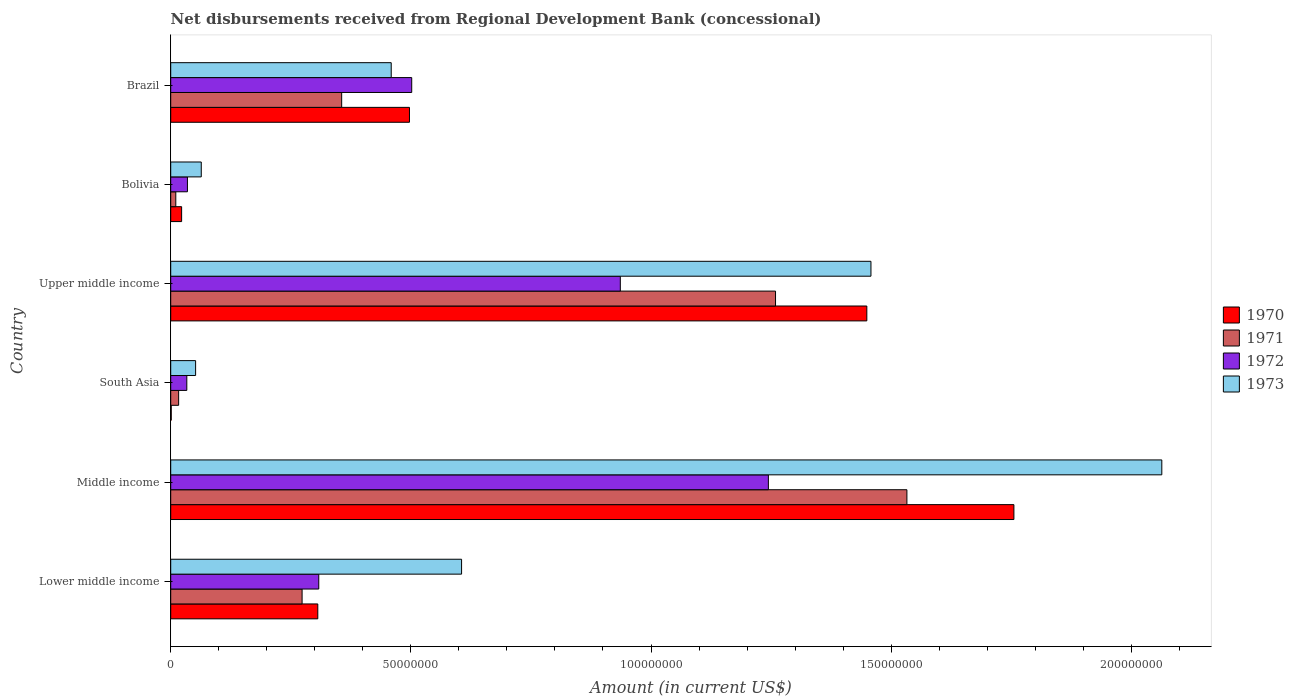How many different coloured bars are there?
Your response must be concise. 4. Are the number of bars on each tick of the Y-axis equal?
Your response must be concise. Yes. How many bars are there on the 1st tick from the top?
Your response must be concise. 4. What is the label of the 4th group of bars from the top?
Provide a short and direct response. South Asia. In how many cases, is the number of bars for a given country not equal to the number of legend labels?
Your response must be concise. 0. What is the amount of disbursements received from Regional Development Bank in 1972 in Bolivia?
Your response must be concise. 3.48e+06. Across all countries, what is the maximum amount of disbursements received from Regional Development Bank in 1970?
Offer a terse response. 1.76e+08. Across all countries, what is the minimum amount of disbursements received from Regional Development Bank in 1973?
Provide a succinct answer. 5.18e+06. In which country was the amount of disbursements received from Regional Development Bank in 1970 minimum?
Provide a short and direct response. South Asia. What is the total amount of disbursements received from Regional Development Bank in 1973 in the graph?
Keep it short and to the point. 4.70e+08. What is the difference between the amount of disbursements received from Regional Development Bank in 1971 in Middle income and that in South Asia?
Keep it short and to the point. 1.52e+08. What is the difference between the amount of disbursements received from Regional Development Bank in 1972 in South Asia and the amount of disbursements received from Regional Development Bank in 1973 in Middle income?
Offer a terse response. -2.03e+08. What is the average amount of disbursements received from Regional Development Bank in 1970 per country?
Provide a succinct answer. 6.72e+07. What is the difference between the amount of disbursements received from Regional Development Bank in 1970 and amount of disbursements received from Regional Development Bank in 1971 in Middle income?
Keep it short and to the point. 2.23e+07. What is the ratio of the amount of disbursements received from Regional Development Bank in 1972 in Bolivia to that in South Asia?
Offer a very short reply. 1.04. Is the difference between the amount of disbursements received from Regional Development Bank in 1970 in South Asia and Upper middle income greater than the difference between the amount of disbursements received from Regional Development Bank in 1971 in South Asia and Upper middle income?
Your answer should be very brief. No. What is the difference between the highest and the second highest amount of disbursements received from Regional Development Bank in 1973?
Provide a short and direct response. 6.06e+07. What is the difference between the highest and the lowest amount of disbursements received from Regional Development Bank in 1971?
Offer a very short reply. 1.52e+08. In how many countries, is the amount of disbursements received from Regional Development Bank in 1970 greater than the average amount of disbursements received from Regional Development Bank in 1970 taken over all countries?
Offer a terse response. 2. Is it the case that in every country, the sum of the amount of disbursements received from Regional Development Bank in 1973 and amount of disbursements received from Regional Development Bank in 1971 is greater than the sum of amount of disbursements received from Regional Development Bank in 1970 and amount of disbursements received from Regional Development Bank in 1972?
Offer a terse response. No. What does the 2nd bar from the top in Lower middle income represents?
Give a very brief answer. 1972. What does the 1st bar from the bottom in Bolivia represents?
Keep it short and to the point. 1970. How many bars are there?
Give a very brief answer. 24. How many countries are there in the graph?
Offer a very short reply. 6. What is the difference between two consecutive major ticks on the X-axis?
Ensure brevity in your answer.  5.00e+07. Are the values on the major ticks of X-axis written in scientific E-notation?
Ensure brevity in your answer.  No. Does the graph contain any zero values?
Keep it short and to the point. No. Does the graph contain grids?
Make the answer very short. No. How many legend labels are there?
Keep it short and to the point. 4. What is the title of the graph?
Your response must be concise. Net disbursements received from Regional Development Bank (concessional). What is the Amount (in current US$) of 1970 in Lower middle income?
Your response must be concise. 3.06e+07. What is the Amount (in current US$) of 1971 in Lower middle income?
Offer a terse response. 2.74e+07. What is the Amount (in current US$) of 1972 in Lower middle income?
Provide a short and direct response. 3.08e+07. What is the Amount (in current US$) in 1973 in Lower middle income?
Offer a terse response. 6.06e+07. What is the Amount (in current US$) in 1970 in Middle income?
Offer a very short reply. 1.76e+08. What is the Amount (in current US$) in 1971 in Middle income?
Offer a terse response. 1.53e+08. What is the Amount (in current US$) of 1972 in Middle income?
Offer a terse response. 1.24e+08. What is the Amount (in current US$) of 1973 in Middle income?
Offer a terse response. 2.06e+08. What is the Amount (in current US$) of 1970 in South Asia?
Provide a short and direct response. 1.09e+05. What is the Amount (in current US$) in 1971 in South Asia?
Offer a very short reply. 1.65e+06. What is the Amount (in current US$) of 1972 in South Asia?
Your answer should be very brief. 3.35e+06. What is the Amount (in current US$) of 1973 in South Asia?
Your response must be concise. 5.18e+06. What is the Amount (in current US$) of 1970 in Upper middle income?
Ensure brevity in your answer.  1.45e+08. What is the Amount (in current US$) in 1971 in Upper middle income?
Offer a terse response. 1.26e+08. What is the Amount (in current US$) of 1972 in Upper middle income?
Make the answer very short. 9.36e+07. What is the Amount (in current US$) of 1973 in Upper middle income?
Provide a short and direct response. 1.46e+08. What is the Amount (in current US$) in 1970 in Bolivia?
Offer a very short reply. 2.27e+06. What is the Amount (in current US$) in 1971 in Bolivia?
Offer a terse response. 1.06e+06. What is the Amount (in current US$) of 1972 in Bolivia?
Give a very brief answer. 3.48e+06. What is the Amount (in current US$) of 1973 in Bolivia?
Offer a terse response. 6.36e+06. What is the Amount (in current US$) of 1970 in Brazil?
Make the answer very short. 4.97e+07. What is the Amount (in current US$) in 1971 in Brazil?
Your answer should be very brief. 3.56e+07. What is the Amount (in current US$) of 1972 in Brazil?
Your answer should be very brief. 5.02e+07. What is the Amount (in current US$) in 1973 in Brazil?
Offer a very short reply. 4.59e+07. Across all countries, what is the maximum Amount (in current US$) in 1970?
Give a very brief answer. 1.76e+08. Across all countries, what is the maximum Amount (in current US$) in 1971?
Provide a succinct answer. 1.53e+08. Across all countries, what is the maximum Amount (in current US$) of 1972?
Give a very brief answer. 1.24e+08. Across all countries, what is the maximum Amount (in current US$) of 1973?
Offer a terse response. 2.06e+08. Across all countries, what is the minimum Amount (in current US$) in 1970?
Your answer should be very brief. 1.09e+05. Across all countries, what is the minimum Amount (in current US$) of 1971?
Offer a very short reply. 1.06e+06. Across all countries, what is the minimum Amount (in current US$) in 1972?
Your answer should be very brief. 3.35e+06. Across all countries, what is the minimum Amount (in current US$) in 1973?
Provide a succinct answer. 5.18e+06. What is the total Amount (in current US$) in 1970 in the graph?
Make the answer very short. 4.03e+08. What is the total Amount (in current US$) of 1971 in the graph?
Your answer should be compact. 3.45e+08. What is the total Amount (in current US$) of 1972 in the graph?
Make the answer very short. 3.06e+08. What is the total Amount (in current US$) in 1973 in the graph?
Offer a very short reply. 4.70e+08. What is the difference between the Amount (in current US$) of 1970 in Lower middle income and that in Middle income?
Ensure brevity in your answer.  -1.45e+08. What is the difference between the Amount (in current US$) in 1971 in Lower middle income and that in Middle income?
Your answer should be very brief. -1.26e+08. What is the difference between the Amount (in current US$) in 1972 in Lower middle income and that in Middle income?
Provide a short and direct response. -9.36e+07. What is the difference between the Amount (in current US$) of 1973 in Lower middle income and that in Middle income?
Make the answer very short. -1.46e+08. What is the difference between the Amount (in current US$) in 1970 in Lower middle income and that in South Asia?
Offer a very short reply. 3.05e+07. What is the difference between the Amount (in current US$) of 1971 in Lower middle income and that in South Asia?
Give a very brief answer. 2.57e+07. What is the difference between the Amount (in current US$) in 1972 in Lower middle income and that in South Asia?
Give a very brief answer. 2.75e+07. What is the difference between the Amount (in current US$) of 1973 in Lower middle income and that in South Asia?
Provide a short and direct response. 5.54e+07. What is the difference between the Amount (in current US$) of 1970 in Lower middle income and that in Upper middle income?
Provide a short and direct response. -1.14e+08. What is the difference between the Amount (in current US$) of 1971 in Lower middle income and that in Upper middle income?
Offer a terse response. -9.86e+07. What is the difference between the Amount (in current US$) of 1972 in Lower middle income and that in Upper middle income?
Provide a succinct answer. -6.28e+07. What is the difference between the Amount (in current US$) in 1973 in Lower middle income and that in Upper middle income?
Provide a succinct answer. -8.52e+07. What is the difference between the Amount (in current US$) of 1970 in Lower middle income and that in Bolivia?
Provide a succinct answer. 2.84e+07. What is the difference between the Amount (in current US$) of 1971 in Lower middle income and that in Bolivia?
Provide a succinct answer. 2.63e+07. What is the difference between the Amount (in current US$) in 1972 in Lower middle income and that in Bolivia?
Provide a succinct answer. 2.73e+07. What is the difference between the Amount (in current US$) of 1973 in Lower middle income and that in Bolivia?
Make the answer very short. 5.42e+07. What is the difference between the Amount (in current US$) in 1970 in Lower middle income and that in Brazil?
Offer a very short reply. -1.91e+07. What is the difference between the Amount (in current US$) in 1971 in Lower middle income and that in Brazil?
Offer a terse response. -8.24e+06. What is the difference between the Amount (in current US$) of 1972 in Lower middle income and that in Brazil?
Offer a terse response. -1.94e+07. What is the difference between the Amount (in current US$) in 1973 in Lower middle income and that in Brazil?
Keep it short and to the point. 1.46e+07. What is the difference between the Amount (in current US$) in 1970 in Middle income and that in South Asia?
Your response must be concise. 1.75e+08. What is the difference between the Amount (in current US$) of 1971 in Middle income and that in South Asia?
Keep it short and to the point. 1.52e+08. What is the difference between the Amount (in current US$) in 1972 in Middle income and that in South Asia?
Ensure brevity in your answer.  1.21e+08. What is the difference between the Amount (in current US$) in 1973 in Middle income and that in South Asia?
Offer a very short reply. 2.01e+08. What is the difference between the Amount (in current US$) in 1970 in Middle income and that in Upper middle income?
Your answer should be very brief. 3.06e+07. What is the difference between the Amount (in current US$) in 1971 in Middle income and that in Upper middle income?
Provide a short and direct response. 2.74e+07. What is the difference between the Amount (in current US$) in 1972 in Middle income and that in Upper middle income?
Your answer should be very brief. 3.08e+07. What is the difference between the Amount (in current US$) of 1973 in Middle income and that in Upper middle income?
Give a very brief answer. 6.06e+07. What is the difference between the Amount (in current US$) of 1970 in Middle income and that in Bolivia?
Offer a very short reply. 1.73e+08. What is the difference between the Amount (in current US$) of 1971 in Middle income and that in Bolivia?
Provide a succinct answer. 1.52e+08. What is the difference between the Amount (in current US$) of 1972 in Middle income and that in Bolivia?
Give a very brief answer. 1.21e+08. What is the difference between the Amount (in current US$) in 1973 in Middle income and that in Bolivia?
Your response must be concise. 2.00e+08. What is the difference between the Amount (in current US$) of 1970 in Middle income and that in Brazil?
Give a very brief answer. 1.26e+08. What is the difference between the Amount (in current US$) in 1971 in Middle income and that in Brazil?
Your response must be concise. 1.18e+08. What is the difference between the Amount (in current US$) in 1972 in Middle income and that in Brazil?
Offer a terse response. 7.43e+07. What is the difference between the Amount (in current US$) of 1973 in Middle income and that in Brazil?
Offer a very short reply. 1.60e+08. What is the difference between the Amount (in current US$) in 1970 in South Asia and that in Upper middle income?
Your answer should be very brief. -1.45e+08. What is the difference between the Amount (in current US$) in 1971 in South Asia and that in Upper middle income?
Keep it short and to the point. -1.24e+08. What is the difference between the Amount (in current US$) in 1972 in South Asia and that in Upper middle income?
Your answer should be very brief. -9.03e+07. What is the difference between the Amount (in current US$) in 1973 in South Asia and that in Upper middle income?
Provide a short and direct response. -1.41e+08. What is the difference between the Amount (in current US$) in 1970 in South Asia and that in Bolivia?
Your answer should be very brief. -2.16e+06. What is the difference between the Amount (in current US$) of 1971 in South Asia and that in Bolivia?
Make the answer very short. 5.92e+05. What is the difference between the Amount (in current US$) of 1972 in South Asia and that in Bolivia?
Ensure brevity in your answer.  -1.30e+05. What is the difference between the Amount (in current US$) in 1973 in South Asia and that in Bolivia?
Offer a very short reply. -1.18e+06. What is the difference between the Amount (in current US$) of 1970 in South Asia and that in Brazil?
Offer a very short reply. -4.96e+07. What is the difference between the Amount (in current US$) of 1971 in South Asia and that in Brazil?
Offer a very short reply. -3.39e+07. What is the difference between the Amount (in current US$) in 1972 in South Asia and that in Brazil?
Keep it short and to the point. -4.68e+07. What is the difference between the Amount (in current US$) in 1973 in South Asia and that in Brazil?
Your answer should be very brief. -4.07e+07. What is the difference between the Amount (in current US$) of 1970 in Upper middle income and that in Bolivia?
Provide a succinct answer. 1.43e+08. What is the difference between the Amount (in current US$) of 1971 in Upper middle income and that in Bolivia?
Your answer should be compact. 1.25e+08. What is the difference between the Amount (in current US$) in 1972 in Upper middle income and that in Bolivia?
Provide a short and direct response. 9.01e+07. What is the difference between the Amount (in current US$) in 1973 in Upper middle income and that in Bolivia?
Give a very brief answer. 1.39e+08. What is the difference between the Amount (in current US$) in 1970 in Upper middle income and that in Brazil?
Keep it short and to the point. 9.52e+07. What is the difference between the Amount (in current US$) in 1971 in Upper middle income and that in Brazil?
Your answer should be very brief. 9.03e+07. What is the difference between the Amount (in current US$) in 1972 in Upper middle income and that in Brazil?
Your response must be concise. 4.34e+07. What is the difference between the Amount (in current US$) of 1973 in Upper middle income and that in Brazil?
Offer a very short reply. 9.99e+07. What is the difference between the Amount (in current US$) of 1970 in Bolivia and that in Brazil?
Provide a short and direct response. -4.74e+07. What is the difference between the Amount (in current US$) of 1971 in Bolivia and that in Brazil?
Make the answer very short. -3.45e+07. What is the difference between the Amount (in current US$) of 1972 in Bolivia and that in Brazil?
Provide a succinct answer. -4.67e+07. What is the difference between the Amount (in current US$) of 1973 in Bolivia and that in Brazil?
Offer a terse response. -3.95e+07. What is the difference between the Amount (in current US$) of 1970 in Lower middle income and the Amount (in current US$) of 1971 in Middle income?
Give a very brief answer. -1.23e+08. What is the difference between the Amount (in current US$) in 1970 in Lower middle income and the Amount (in current US$) in 1972 in Middle income?
Your answer should be very brief. -9.38e+07. What is the difference between the Amount (in current US$) of 1970 in Lower middle income and the Amount (in current US$) of 1973 in Middle income?
Make the answer very short. -1.76e+08. What is the difference between the Amount (in current US$) of 1971 in Lower middle income and the Amount (in current US$) of 1972 in Middle income?
Give a very brief answer. -9.71e+07. What is the difference between the Amount (in current US$) in 1971 in Lower middle income and the Amount (in current US$) in 1973 in Middle income?
Give a very brief answer. -1.79e+08. What is the difference between the Amount (in current US$) in 1972 in Lower middle income and the Amount (in current US$) in 1973 in Middle income?
Give a very brief answer. -1.76e+08. What is the difference between the Amount (in current US$) in 1970 in Lower middle income and the Amount (in current US$) in 1971 in South Asia?
Your answer should be very brief. 2.90e+07. What is the difference between the Amount (in current US$) of 1970 in Lower middle income and the Amount (in current US$) of 1972 in South Asia?
Your response must be concise. 2.73e+07. What is the difference between the Amount (in current US$) of 1970 in Lower middle income and the Amount (in current US$) of 1973 in South Asia?
Provide a succinct answer. 2.54e+07. What is the difference between the Amount (in current US$) in 1971 in Lower middle income and the Amount (in current US$) in 1972 in South Asia?
Provide a succinct answer. 2.40e+07. What is the difference between the Amount (in current US$) in 1971 in Lower middle income and the Amount (in current US$) in 1973 in South Asia?
Keep it short and to the point. 2.22e+07. What is the difference between the Amount (in current US$) in 1972 in Lower middle income and the Amount (in current US$) in 1973 in South Asia?
Offer a terse response. 2.56e+07. What is the difference between the Amount (in current US$) in 1970 in Lower middle income and the Amount (in current US$) in 1971 in Upper middle income?
Offer a very short reply. -9.53e+07. What is the difference between the Amount (in current US$) in 1970 in Lower middle income and the Amount (in current US$) in 1972 in Upper middle income?
Your answer should be compact. -6.30e+07. What is the difference between the Amount (in current US$) of 1970 in Lower middle income and the Amount (in current US$) of 1973 in Upper middle income?
Keep it short and to the point. -1.15e+08. What is the difference between the Amount (in current US$) of 1971 in Lower middle income and the Amount (in current US$) of 1972 in Upper middle income?
Provide a succinct answer. -6.63e+07. What is the difference between the Amount (in current US$) in 1971 in Lower middle income and the Amount (in current US$) in 1973 in Upper middle income?
Give a very brief answer. -1.18e+08. What is the difference between the Amount (in current US$) of 1972 in Lower middle income and the Amount (in current US$) of 1973 in Upper middle income?
Provide a short and direct response. -1.15e+08. What is the difference between the Amount (in current US$) in 1970 in Lower middle income and the Amount (in current US$) in 1971 in Bolivia?
Provide a succinct answer. 2.96e+07. What is the difference between the Amount (in current US$) in 1970 in Lower middle income and the Amount (in current US$) in 1972 in Bolivia?
Your response must be concise. 2.71e+07. What is the difference between the Amount (in current US$) of 1970 in Lower middle income and the Amount (in current US$) of 1973 in Bolivia?
Your answer should be very brief. 2.43e+07. What is the difference between the Amount (in current US$) of 1971 in Lower middle income and the Amount (in current US$) of 1972 in Bolivia?
Your answer should be compact. 2.39e+07. What is the difference between the Amount (in current US$) in 1971 in Lower middle income and the Amount (in current US$) in 1973 in Bolivia?
Provide a short and direct response. 2.10e+07. What is the difference between the Amount (in current US$) in 1972 in Lower middle income and the Amount (in current US$) in 1973 in Bolivia?
Offer a very short reply. 2.45e+07. What is the difference between the Amount (in current US$) in 1970 in Lower middle income and the Amount (in current US$) in 1971 in Brazil?
Ensure brevity in your answer.  -4.97e+06. What is the difference between the Amount (in current US$) in 1970 in Lower middle income and the Amount (in current US$) in 1972 in Brazil?
Your answer should be compact. -1.96e+07. What is the difference between the Amount (in current US$) in 1970 in Lower middle income and the Amount (in current US$) in 1973 in Brazil?
Offer a very short reply. -1.53e+07. What is the difference between the Amount (in current US$) of 1971 in Lower middle income and the Amount (in current US$) of 1972 in Brazil?
Ensure brevity in your answer.  -2.28e+07. What is the difference between the Amount (in current US$) of 1971 in Lower middle income and the Amount (in current US$) of 1973 in Brazil?
Your response must be concise. -1.86e+07. What is the difference between the Amount (in current US$) of 1972 in Lower middle income and the Amount (in current US$) of 1973 in Brazil?
Offer a terse response. -1.51e+07. What is the difference between the Amount (in current US$) in 1970 in Middle income and the Amount (in current US$) in 1971 in South Asia?
Ensure brevity in your answer.  1.74e+08. What is the difference between the Amount (in current US$) of 1970 in Middle income and the Amount (in current US$) of 1972 in South Asia?
Make the answer very short. 1.72e+08. What is the difference between the Amount (in current US$) in 1970 in Middle income and the Amount (in current US$) in 1973 in South Asia?
Provide a short and direct response. 1.70e+08. What is the difference between the Amount (in current US$) in 1971 in Middle income and the Amount (in current US$) in 1972 in South Asia?
Your answer should be compact. 1.50e+08. What is the difference between the Amount (in current US$) in 1971 in Middle income and the Amount (in current US$) in 1973 in South Asia?
Offer a very short reply. 1.48e+08. What is the difference between the Amount (in current US$) of 1972 in Middle income and the Amount (in current US$) of 1973 in South Asia?
Keep it short and to the point. 1.19e+08. What is the difference between the Amount (in current US$) in 1970 in Middle income and the Amount (in current US$) in 1971 in Upper middle income?
Your response must be concise. 4.96e+07. What is the difference between the Amount (in current US$) in 1970 in Middle income and the Amount (in current US$) in 1972 in Upper middle income?
Give a very brief answer. 8.19e+07. What is the difference between the Amount (in current US$) of 1970 in Middle income and the Amount (in current US$) of 1973 in Upper middle income?
Your response must be concise. 2.98e+07. What is the difference between the Amount (in current US$) in 1971 in Middle income and the Amount (in current US$) in 1972 in Upper middle income?
Make the answer very short. 5.97e+07. What is the difference between the Amount (in current US$) of 1971 in Middle income and the Amount (in current US$) of 1973 in Upper middle income?
Give a very brief answer. 7.49e+06. What is the difference between the Amount (in current US$) of 1972 in Middle income and the Amount (in current US$) of 1973 in Upper middle income?
Your answer should be very brief. -2.14e+07. What is the difference between the Amount (in current US$) of 1970 in Middle income and the Amount (in current US$) of 1971 in Bolivia?
Ensure brevity in your answer.  1.74e+08. What is the difference between the Amount (in current US$) in 1970 in Middle income and the Amount (in current US$) in 1972 in Bolivia?
Your answer should be compact. 1.72e+08. What is the difference between the Amount (in current US$) in 1970 in Middle income and the Amount (in current US$) in 1973 in Bolivia?
Your answer should be very brief. 1.69e+08. What is the difference between the Amount (in current US$) of 1971 in Middle income and the Amount (in current US$) of 1972 in Bolivia?
Your answer should be very brief. 1.50e+08. What is the difference between the Amount (in current US$) of 1971 in Middle income and the Amount (in current US$) of 1973 in Bolivia?
Your response must be concise. 1.47e+08. What is the difference between the Amount (in current US$) in 1972 in Middle income and the Amount (in current US$) in 1973 in Bolivia?
Make the answer very short. 1.18e+08. What is the difference between the Amount (in current US$) in 1970 in Middle income and the Amount (in current US$) in 1971 in Brazil?
Your response must be concise. 1.40e+08. What is the difference between the Amount (in current US$) of 1970 in Middle income and the Amount (in current US$) of 1972 in Brazil?
Make the answer very short. 1.25e+08. What is the difference between the Amount (in current US$) of 1970 in Middle income and the Amount (in current US$) of 1973 in Brazil?
Your answer should be compact. 1.30e+08. What is the difference between the Amount (in current US$) of 1971 in Middle income and the Amount (in current US$) of 1972 in Brazil?
Make the answer very short. 1.03e+08. What is the difference between the Amount (in current US$) in 1971 in Middle income and the Amount (in current US$) in 1973 in Brazil?
Your answer should be very brief. 1.07e+08. What is the difference between the Amount (in current US$) of 1972 in Middle income and the Amount (in current US$) of 1973 in Brazil?
Offer a very short reply. 7.85e+07. What is the difference between the Amount (in current US$) in 1970 in South Asia and the Amount (in current US$) in 1971 in Upper middle income?
Ensure brevity in your answer.  -1.26e+08. What is the difference between the Amount (in current US$) of 1970 in South Asia and the Amount (in current US$) of 1972 in Upper middle income?
Provide a short and direct response. -9.35e+07. What is the difference between the Amount (in current US$) in 1970 in South Asia and the Amount (in current US$) in 1973 in Upper middle income?
Give a very brief answer. -1.46e+08. What is the difference between the Amount (in current US$) in 1971 in South Asia and the Amount (in current US$) in 1972 in Upper middle income?
Your answer should be very brief. -9.20e+07. What is the difference between the Amount (in current US$) of 1971 in South Asia and the Amount (in current US$) of 1973 in Upper middle income?
Provide a succinct answer. -1.44e+08. What is the difference between the Amount (in current US$) of 1972 in South Asia and the Amount (in current US$) of 1973 in Upper middle income?
Offer a terse response. -1.42e+08. What is the difference between the Amount (in current US$) in 1970 in South Asia and the Amount (in current US$) in 1971 in Bolivia?
Make the answer very short. -9.49e+05. What is the difference between the Amount (in current US$) in 1970 in South Asia and the Amount (in current US$) in 1972 in Bolivia?
Offer a very short reply. -3.37e+06. What is the difference between the Amount (in current US$) in 1970 in South Asia and the Amount (in current US$) in 1973 in Bolivia?
Offer a terse response. -6.25e+06. What is the difference between the Amount (in current US$) in 1971 in South Asia and the Amount (in current US$) in 1972 in Bolivia?
Your answer should be very brief. -1.83e+06. What is the difference between the Amount (in current US$) of 1971 in South Asia and the Amount (in current US$) of 1973 in Bolivia?
Offer a terse response. -4.71e+06. What is the difference between the Amount (in current US$) in 1972 in South Asia and the Amount (in current US$) in 1973 in Bolivia?
Keep it short and to the point. -3.01e+06. What is the difference between the Amount (in current US$) of 1970 in South Asia and the Amount (in current US$) of 1971 in Brazil?
Your response must be concise. -3.55e+07. What is the difference between the Amount (in current US$) in 1970 in South Asia and the Amount (in current US$) in 1972 in Brazil?
Offer a very short reply. -5.01e+07. What is the difference between the Amount (in current US$) in 1970 in South Asia and the Amount (in current US$) in 1973 in Brazil?
Make the answer very short. -4.58e+07. What is the difference between the Amount (in current US$) of 1971 in South Asia and the Amount (in current US$) of 1972 in Brazil?
Provide a succinct answer. -4.85e+07. What is the difference between the Amount (in current US$) in 1971 in South Asia and the Amount (in current US$) in 1973 in Brazil?
Your answer should be very brief. -4.43e+07. What is the difference between the Amount (in current US$) of 1972 in South Asia and the Amount (in current US$) of 1973 in Brazil?
Your answer should be compact. -4.26e+07. What is the difference between the Amount (in current US$) in 1970 in Upper middle income and the Amount (in current US$) in 1971 in Bolivia?
Give a very brief answer. 1.44e+08. What is the difference between the Amount (in current US$) in 1970 in Upper middle income and the Amount (in current US$) in 1972 in Bolivia?
Keep it short and to the point. 1.41e+08. What is the difference between the Amount (in current US$) of 1970 in Upper middle income and the Amount (in current US$) of 1973 in Bolivia?
Your answer should be very brief. 1.39e+08. What is the difference between the Amount (in current US$) in 1971 in Upper middle income and the Amount (in current US$) in 1972 in Bolivia?
Ensure brevity in your answer.  1.22e+08. What is the difference between the Amount (in current US$) in 1971 in Upper middle income and the Amount (in current US$) in 1973 in Bolivia?
Your answer should be compact. 1.20e+08. What is the difference between the Amount (in current US$) of 1972 in Upper middle income and the Amount (in current US$) of 1973 in Bolivia?
Provide a succinct answer. 8.72e+07. What is the difference between the Amount (in current US$) in 1970 in Upper middle income and the Amount (in current US$) in 1971 in Brazil?
Offer a very short reply. 1.09e+08. What is the difference between the Amount (in current US$) in 1970 in Upper middle income and the Amount (in current US$) in 1972 in Brazil?
Offer a terse response. 9.48e+07. What is the difference between the Amount (in current US$) of 1970 in Upper middle income and the Amount (in current US$) of 1973 in Brazil?
Your answer should be compact. 9.90e+07. What is the difference between the Amount (in current US$) in 1971 in Upper middle income and the Amount (in current US$) in 1972 in Brazil?
Provide a succinct answer. 7.57e+07. What is the difference between the Amount (in current US$) in 1971 in Upper middle income and the Amount (in current US$) in 1973 in Brazil?
Provide a succinct answer. 8.00e+07. What is the difference between the Amount (in current US$) in 1972 in Upper middle income and the Amount (in current US$) in 1973 in Brazil?
Your response must be concise. 4.77e+07. What is the difference between the Amount (in current US$) of 1970 in Bolivia and the Amount (in current US$) of 1971 in Brazil?
Ensure brevity in your answer.  -3.33e+07. What is the difference between the Amount (in current US$) of 1970 in Bolivia and the Amount (in current US$) of 1972 in Brazil?
Keep it short and to the point. -4.79e+07. What is the difference between the Amount (in current US$) in 1970 in Bolivia and the Amount (in current US$) in 1973 in Brazil?
Provide a short and direct response. -4.36e+07. What is the difference between the Amount (in current US$) in 1971 in Bolivia and the Amount (in current US$) in 1972 in Brazil?
Provide a short and direct response. -4.91e+07. What is the difference between the Amount (in current US$) in 1971 in Bolivia and the Amount (in current US$) in 1973 in Brazil?
Your answer should be very brief. -4.49e+07. What is the difference between the Amount (in current US$) of 1972 in Bolivia and the Amount (in current US$) of 1973 in Brazil?
Your response must be concise. -4.24e+07. What is the average Amount (in current US$) in 1970 per country?
Your answer should be compact. 6.72e+07. What is the average Amount (in current US$) of 1971 per country?
Give a very brief answer. 5.75e+07. What is the average Amount (in current US$) in 1972 per country?
Your answer should be very brief. 5.10e+07. What is the average Amount (in current US$) of 1973 per country?
Provide a succinct answer. 7.84e+07. What is the difference between the Amount (in current US$) of 1970 and Amount (in current US$) of 1971 in Lower middle income?
Give a very brief answer. 3.27e+06. What is the difference between the Amount (in current US$) in 1970 and Amount (in current US$) in 1972 in Lower middle income?
Offer a terse response. -2.02e+05. What is the difference between the Amount (in current US$) of 1970 and Amount (in current US$) of 1973 in Lower middle income?
Provide a short and direct response. -2.99e+07. What is the difference between the Amount (in current US$) of 1971 and Amount (in current US$) of 1972 in Lower middle income?
Give a very brief answer. -3.47e+06. What is the difference between the Amount (in current US$) in 1971 and Amount (in current US$) in 1973 in Lower middle income?
Make the answer very short. -3.32e+07. What is the difference between the Amount (in current US$) of 1972 and Amount (in current US$) of 1973 in Lower middle income?
Provide a short and direct response. -2.97e+07. What is the difference between the Amount (in current US$) of 1970 and Amount (in current US$) of 1971 in Middle income?
Keep it short and to the point. 2.23e+07. What is the difference between the Amount (in current US$) of 1970 and Amount (in current US$) of 1972 in Middle income?
Provide a short and direct response. 5.11e+07. What is the difference between the Amount (in current US$) in 1970 and Amount (in current US$) in 1973 in Middle income?
Your response must be concise. -3.08e+07. What is the difference between the Amount (in current US$) in 1971 and Amount (in current US$) in 1972 in Middle income?
Keep it short and to the point. 2.88e+07. What is the difference between the Amount (in current US$) in 1971 and Amount (in current US$) in 1973 in Middle income?
Your answer should be very brief. -5.31e+07. What is the difference between the Amount (in current US$) in 1972 and Amount (in current US$) in 1973 in Middle income?
Provide a succinct answer. -8.19e+07. What is the difference between the Amount (in current US$) of 1970 and Amount (in current US$) of 1971 in South Asia?
Provide a succinct answer. -1.54e+06. What is the difference between the Amount (in current US$) of 1970 and Amount (in current US$) of 1972 in South Asia?
Make the answer very short. -3.24e+06. What is the difference between the Amount (in current US$) of 1970 and Amount (in current US$) of 1973 in South Asia?
Your response must be concise. -5.08e+06. What is the difference between the Amount (in current US$) in 1971 and Amount (in current US$) in 1972 in South Asia?
Make the answer very short. -1.70e+06. What is the difference between the Amount (in current US$) in 1971 and Amount (in current US$) in 1973 in South Asia?
Your response must be concise. -3.53e+06. What is the difference between the Amount (in current US$) in 1972 and Amount (in current US$) in 1973 in South Asia?
Keep it short and to the point. -1.83e+06. What is the difference between the Amount (in current US$) in 1970 and Amount (in current US$) in 1971 in Upper middle income?
Give a very brief answer. 1.90e+07. What is the difference between the Amount (in current US$) in 1970 and Amount (in current US$) in 1972 in Upper middle income?
Offer a very short reply. 5.13e+07. What is the difference between the Amount (in current US$) in 1970 and Amount (in current US$) in 1973 in Upper middle income?
Make the answer very short. -8.58e+05. What is the difference between the Amount (in current US$) in 1971 and Amount (in current US$) in 1972 in Upper middle income?
Provide a succinct answer. 3.23e+07. What is the difference between the Amount (in current US$) of 1971 and Amount (in current US$) of 1973 in Upper middle income?
Your answer should be compact. -1.99e+07. What is the difference between the Amount (in current US$) of 1972 and Amount (in current US$) of 1973 in Upper middle income?
Your answer should be compact. -5.22e+07. What is the difference between the Amount (in current US$) in 1970 and Amount (in current US$) in 1971 in Bolivia?
Provide a short and direct response. 1.21e+06. What is the difference between the Amount (in current US$) in 1970 and Amount (in current US$) in 1972 in Bolivia?
Offer a very short reply. -1.21e+06. What is the difference between the Amount (in current US$) of 1970 and Amount (in current US$) of 1973 in Bolivia?
Offer a terse response. -4.09e+06. What is the difference between the Amount (in current US$) of 1971 and Amount (in current US$) of 1972 in Bolivia?
Make the answer very short. -2.42e+06. What is the difference between the Amount (in current US$) in 1971 and Amount (in current US$) in 1973 in Bolivia?
Your answer should be compact. -5.30e+06. What is the difference between the Amount (in current US$) in 1972 and Amount (in current US$) in 1973 in Bolivia?
Make the answer very short. -2.88e+06. What is the difference between the Amount (in current US$) in 1970 and Amount (in current US$) in 1971 in Brazil?
Keep it short and to the point. 1.41e+07. What is the difference between the Amount (in current US$) of 1970 and Amount (in current US$) of 1972 in Brazil?
Your response must be concise. -4.68e+05. What is the difference between the Amount (in current US$) in 1970 and Amount (in current US$) in 1973 in Brazil?
Keep it short and to the point. 3.80e+06. What is the difference between the Amount (in current US$) in 1971 and Amount (in current US$) in 1972 in Brazil?
Provide a succinct answer. -1.46e+07. What is the difference between the Amount (in current US$) in 1971 and Amount (in current US$) in 1973 in Brazil?
Your response must be concise. -1.03e+07. What is the difference between the Amount (in current US$) in 1972 and Amount (in current US$) in 1973 in Brazil?
Provide a short and direct response. 4.27e+06. What is the ratio of the Amount (in current US$) in 1970 in Lower middle income to that in Middle income?
Your response must be concise. 0.17. What is the ratio of the Amount (in current US$) in 1971 in Lower middle income to that in Middle income?
Provide a succinct answer. 0.18. What is the ratio of the Amount (in current US$) of 1972 in Lower middle income to that in Middle income?
Make the answer very short. 0.25. What is the ratio of the Amount (in current US$) of 1973 in Lower middle income to that in Middle income?
Your answer should be very brief. 0.29. What is the ratio of the Amount (in current US$) in 1970 in Lower middle income to that in South Asia?
Provide a short and direct response. 280.94. What is the ratio of the Amount (in current US$) in 1971 in Lower middle income to that in South Asia?
Your answer should be very brief. 16.58. What is the ratio of the Amount (in current US$) of 1972 in Lower middle income to that in South Asia?
Make the answer very short. 9.2. What is the ratio of the Amount (in current US$) of 1973 in Lower middle income to that in South Asia?
Provide a short and direct response. 11.68. What is the ratio of the Amount (in current US$) of 1970 in Lower middle income to that in Upper middle income?
Make the answer very short. 0.21. What is the ratio of the Amount (in current US$) of 1971 in Lower middle income to that in Upper middle income?
Offer a terse response. 0.22. What is the ratio of the Amount (in current US$) of 1972 in Lower middle income to that in Upper middle income?
Make the answer very short. 0.33. What is the ratio of the Amount (in current US$) in 1973 in Lower middle income to that in Upper middle income?
Your response must be concise. 0.42. What is the ratio of the Amount (in current US$) in 1970 in Lower middle income to that in Bolivia?
Offer a terse response. 13.49. What is the ratio of the Amount (in current US$) of 1971 in Lower middle income to that in Bolivia?
Offer a very short reply. 25.85. What is the ratio of the Amount (in current US$) in 1972 in Lower middle income to that in Bolivia?
Your answer should be very brief. 8.86. What is the ratio of the Amount (in current US$) in 1973 in Lower middle income to that in Bolivia?
Provide a succinct answer. 9.52. What is the ratio of the Amount (in current US$) of 1970 in Lower middle income to that in Brazil?
Your answer should be compact. 0.62. What is the ratio of the Amount (in current US$) of 1971 in Lower middle income to that in Brazil?
Keep it short and to the point. 0.77. What is the ratio of the Amount (in current US$) of 1972 in Lower middle income to that in Brazil?
Provide a short and direct response. 0.61. What is the ratio of the Amount (in current US$) in 1973 in Lower middle income to that in Brazil?
Give a very brief answer. 1.32. What is the ratio of the Amount (in current US$) of 1970 in Middle income to that in South Asia?
Provide a succinct answer. 1610.58. What is the ratio of the Amount (in current US$) of 1971 in Middle income to that in South Asia?
Provide a short and direct response. 92.89. What is the ratio of the Amount (in current US$) in 1972 in Middle income to that in South Asia?
Your response must be concise. 37.14. What is the ratio of the Amount (in current US$) of 1973 in Middle income to that in South Asia?
Provide a succinct answer. 39.8. What is the ratio of the Amount (in current US$) of 1970 in Middle income to that in Upper middle income?
Provide a succinct answer. 1.21. What is the ratio of the Amount (in current US$) of 1971 in Middle income to that in Upper middle income?
Your response must be concise. 1.22. What is the ratio of the Amount (in current US$) in 1972 in Middle income to that in Upper middle income?
Provide a succinct answer. 1.33. What is the ratio of the Amount (in current US$) in 1973 in Middle income to that in Upper middle income?
Ensure brevity in your answer.  1.42. What is the ratio of the Amount (in current US$) of 1970 in Middle income to that in Bolivia?
Your answer should be compact. 77.34. What is the ratio of the Amount (in current US$) of 1971 in Middle income to that in Bolivia?
Make the answer very short. 144.87. What is the ratio of the Amount (in current US$) in 1972 in Middle income to that in Bolivia?
Provide a succinct answer. 35.76. What is the ratio of the Amount (in current US$) of 1973 in Middle income to that in Bolivia?
Make the answer very short. 32.44. What is the ratio of the Amount (in current US$) in 1970 in Middle income to that in Brazil?
Offer a very short reply. 3.53. What is the ratio of the Amount (in current US$) of 1971 in Middle income to that in Brazil?
Offer a terse response. 4.31. What is the ratio of the Amount (in current US$) in 1972 in Middle income to that in Brazil?
Offer a very short reply. 2.48. What is the ratio of the Amount (in current US$) of 1973 in Middle income to that in Brazil?
Provide a succinct answer. 4.49. What is the ratio of the Amount (in current US$) of 1970 in South Asia to that in Upper middle income?
Your answer should be very brief. 0. What is the ratio of the Amount (in current US$) of 1971 in South Asia to that in Upper middle income?
Provide a short and direct response. 0.01. What is the ratio of the Amount (in current US$) of 1972 in South Asia to that in Upper middle income?
Ensure brevity in your answer.  0.04. What is the ratio of the Amount (in current US$) of 1973 in South Asia to that in Upper middle income?
Your answer should be compact. 0.04. What is the ratio of the Amount (in current US$) in 1970 in South Asia to that in Bolivia?
Ensure brevity in your answer.  0.05. What is the ratio of the Amount (in current US$) in 1971 in South Asia to that in Bolivia?
Give a very brief answer. 1.56. What is the ratio of the Amount (in current US$) in 1972 in South Asia to that in Bolivia?
Your response must be concise. 0.96. What is the ratio of the Amount (in current US$) in 1973 in South Asia to that in Bolivia?
Give a very brief answer. 0.82. What is the ratio of the Amount (in current US$) of 1970 in South Asia to that in Brazil?
Your answer should be compact. 0. What is the ratio of the Amount (in current US$) of 1971 in South Asia to that in Brazil?
Offer a terse response. 0.05. What is the ratio of the Amount (in current US$) in 1972 in South Asia to that in Brazil?
Provide a short and direct response. 0.07. What is the ratio of the Amount (in current US$) of 1973 in South Asia to that in Brazil?
Ensure brevity in your answer.  0.11. What is the ratio of the Amount (in current US$) in 1970 in Upper middle income to that in Bolivia?
Your answer should be compact. 63.85. What is the ratio of the Amount (in current US$) in 1971 in Upper middle income to that in Bolivia?
Provide a succinct answer. 119.02. What is the ratio of the Amount (in current US$) of 1972 in Upper middle income to that in Bolivia?
Make the answer very short. 26.9. What is the ratio of the Amount (in current US$) of 1973 in Upper middle income to that in Bolivia?
Make the answer very short. 22.92. What is the ratio of the Amount (in current US$) in 1970 in Upper middle income to that in Brazil?
Give a very brief answer. 2.92. What is the ratio of the Amount (in current US$) of 1971 in Upper middle income to that in Brazil?
Make the answer very short. 3.54. What is the ratio of the Amount (in current US$) of 1972 in Upper middle income to that in Brazil?
Make the answer very short. 1.87. What is the ratio of the Amount (in current US$) in 1973 in Upper middle income to that in Brazil?
Provide a short and direct response. 3.18. What is the ratio of the Amount (in current US$) in 1970 in Bolivia to that in Brazil?
Keep it short and to the point. 0.05. What is the ratio of the Amount (in current US$) of 1971 in Bolivia to that in Brazil?
Provide a succinct answer. 0.03. What is the ratio of the Amount (in current US$) in 1972 in Bolivia to that in Brazil?
Your answer should be very brief. 0.07. What is the ratio of the Amount (in current US$) of 1973 in Bolivia to that in Brazil?
Keep it short and to the point. 0.14. What is the difference between the highest and the second highest Amount (in current US$) of 1970?
Offer a terse response. 3.06e+07. What is the difference between the highest and the second highest Amount (in current US$) of 1971?
Offer a terse response. 2.74e+07. What is the difference between the highest and the second highest Amount (in current US$) in 1972?
Provide a succinct answer. 3.08e+07. What is the difference between the highest and the second highest Amount (in current US$) of 1973?
Provide a short and direct response. 6.06e+07. What is the difference between the highest and the lowest Amount (in current US$) in 1970?
Offer a terse response. 1.75e+08. What is the difference between the highest and the lowest Amount (in current US$) of 1971?
Make the answer very short. 1.52e+08. What is the difference between the highest and the lowest Amount (in current US$) of 1972?
Provide a succinct answer. 1.21e+08. What is the difference between the highest and the lowest Amount (in current US$) of 1973?
Provide a succinct answer. 2.01e+08. 